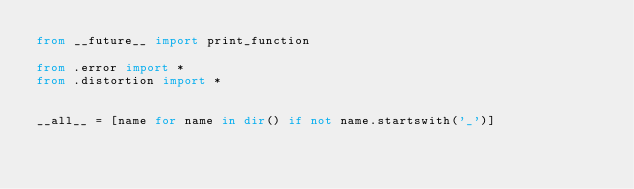Convert code to text. <code><loc_0><loc_0><loc_500><loc_500><_Python_>from __future__ import print_function

from .error import *
from .distortion import *


__all__ = [name for name in dir() if not name.startswith('_')]</code> 